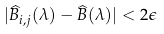<formula> <loc_0><loc_0><loc_500><loc_500>| \widehat { B } _ { i , j } ( \lambda ) - \widehat { B } ( \lambda ) | < 2 \epsilon</formula> 